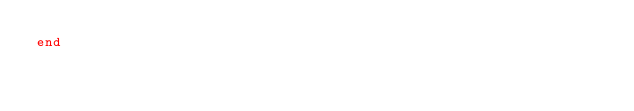Convert code to text. <code><loc_0><loc_0><loc_500><loc_500><_Ruby_>end
</code> 